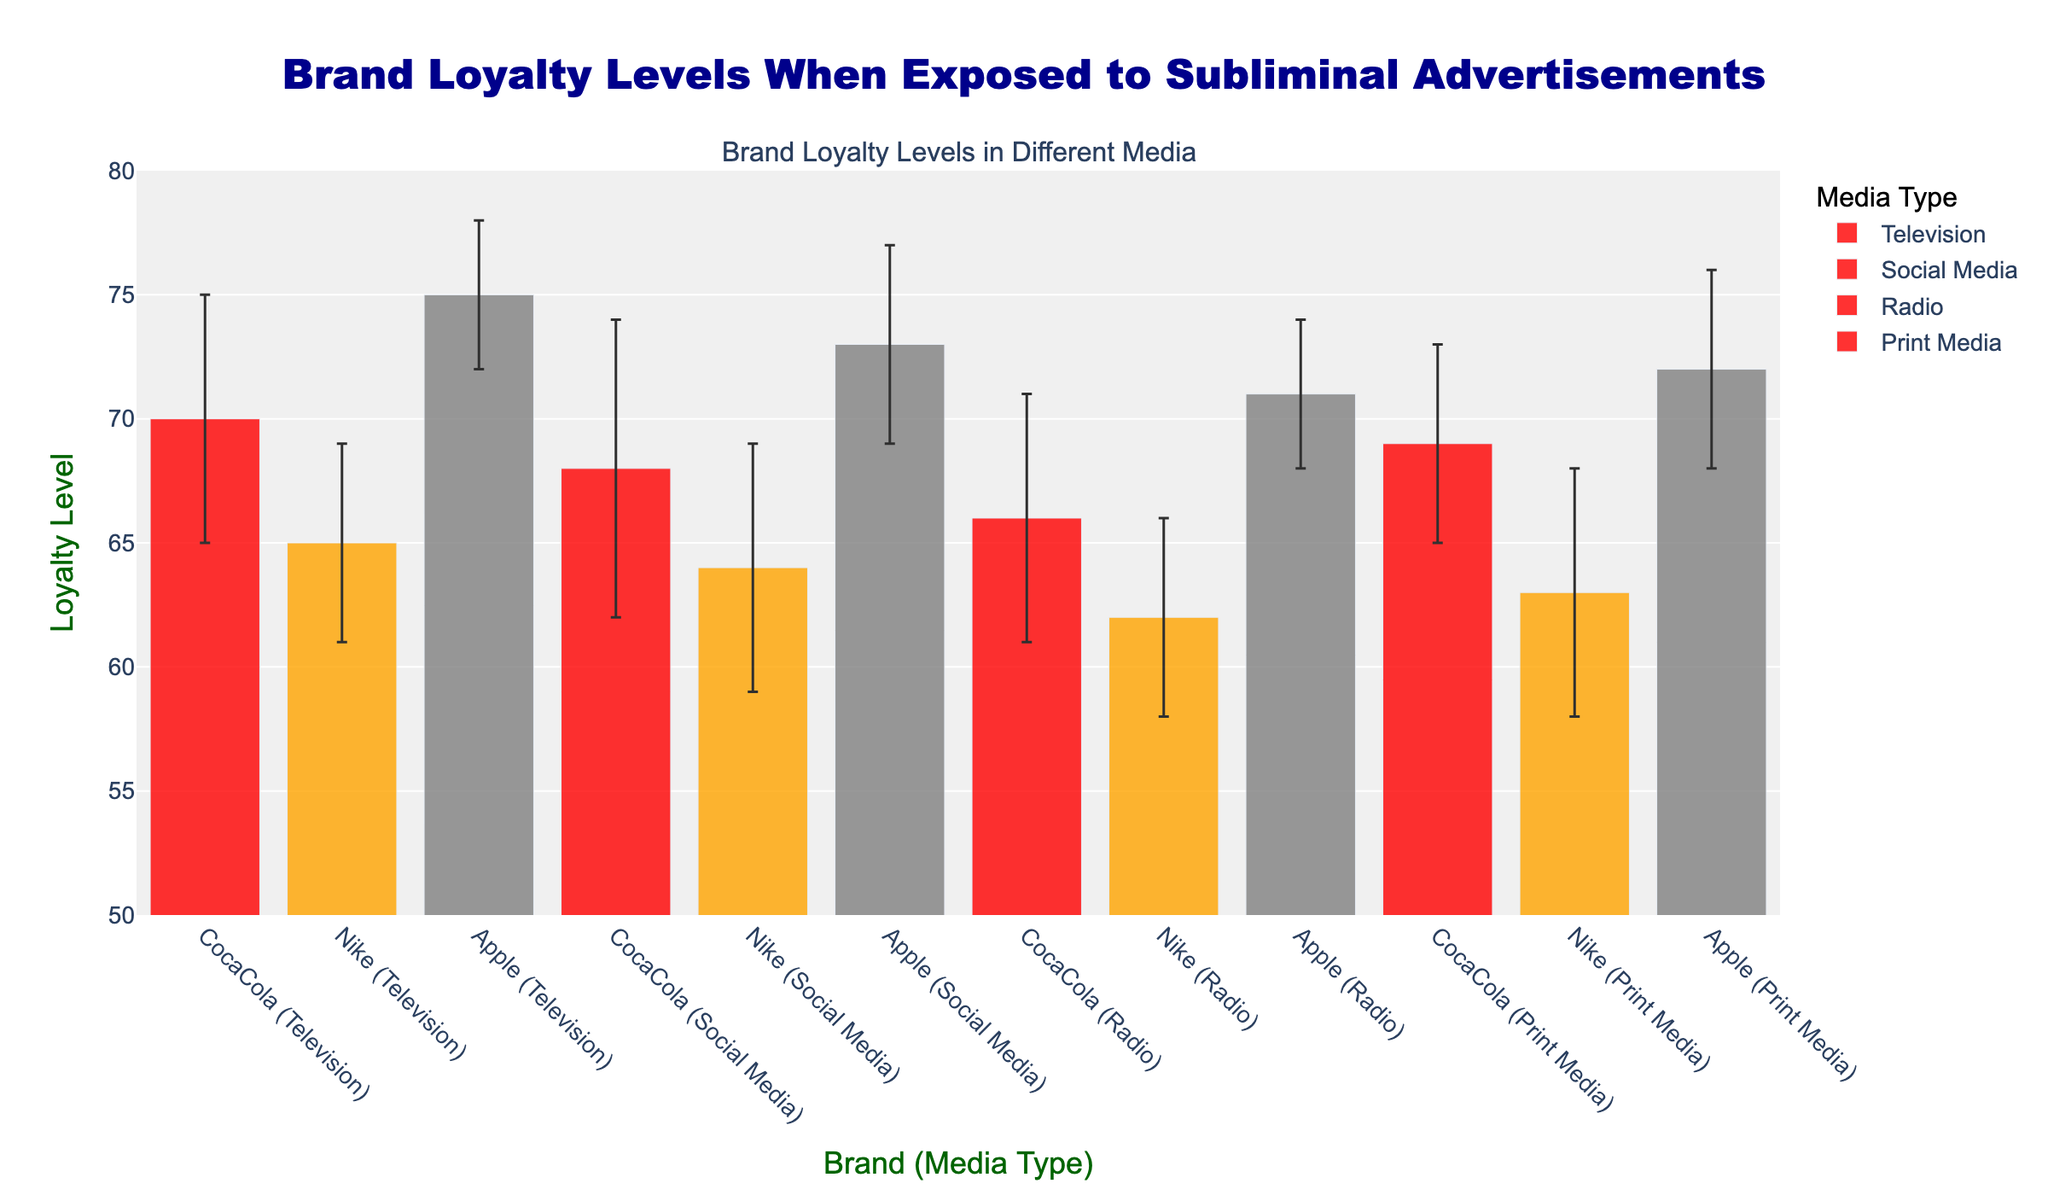Which media type results in the highest mean loyalty level for Apple? To answer this, look for the bar with the highest mean loyalty level for Apple in different media types. The highest bar for Apple is in Television.
Answer: Television What is the mean loyalty level for Nike in Social Media? Look at the bar representing Nike in the Social Media group and read the mean loyalty level. The mean loyalty level for Nike in Social Media is 64.
Answer: 64 What is the difference in mean loyalty levels for CocaCola between Television and Radio? Subtract the mean loyalty level for CocaCola in Radio (66) from that in Television (70). 70 - 66 = 4.
Answer: 4 Which brand shows the smallest variation in loyalty levels across all media types? Compare the standard deviation of loyalty levels for all brands. Apple has the smallest range of standard deviations (from 3 to 4).
Answer: Apple Which media type has the highest average mean loyalty level across all brands? Calculate the average mean loyalty level for each media type: 
- Television: (70 + 65 + 75) / 3 = 70
- Social Media: (68 + 64 + 73) / 3 = 68.33
- Radio: (66 + 62 + 71) / 3 = 66.33
- Print Media: (69 + 63 + 72) / 3 = 68
Television has the highest average mean loyalty level.
Answer: Television What is the range of the mean loyalty levels for CocaCola across all media types? Identify the highest and lowest mean loyalty levels for CocaCola in different media types (highest: 70 in Television, lowest: 66 in Radio). The range is 70 - 66 = 4.
Answer: 4 Which brand and media type combination has the highest standard deviation in loyalty levels? Compare the standard deviations for all brand and media type combinations. CocaCola in Social Media has the highest standard deviation (6).
Answer: CocaCola in Social Media What is the combined mean loyalty level for Apple across all media types? Sum up the mean loyalty levels for Apple in each media type and then calculate the average. (75 + 73 + 71 + 72) / 4 = 72.75.
Answer: 72.75 Is the mean loyalty level for CocaCola in Print Media higher than for Nike in Radio? Compare the mean loyalty levels: CocaCola in Print Media is 69, Nike in Radio is 62. Yes, 69 is higher than 62.
Answer: Yes Which brand has the highest loyalty level in Social Media? Look for the highest bar in the Social Media group. Apple has the highest mean loyalty level in Social Media at 73.
Answer: Apple 